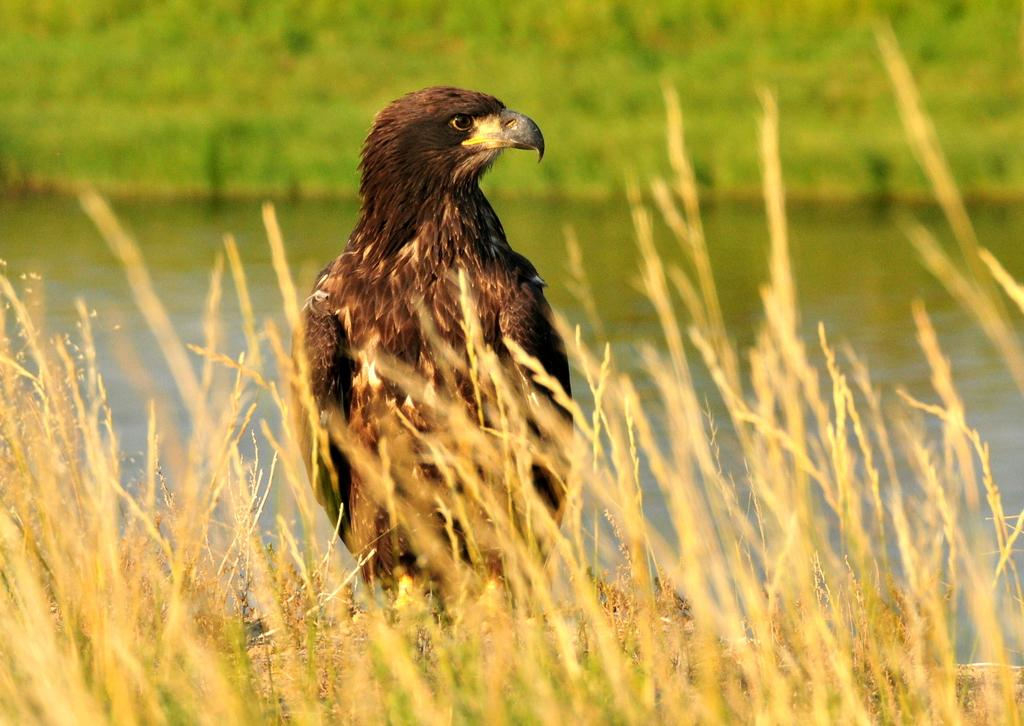What animal is the main subject of the picture? There is an eagle in the picture. In which direction is the eagle facing? The eagle is facing towards the right. What type of vegetation can be seen at the bottom of the image? There are dried plants at the bottom of the image. What natural features can be seen in the background of the image? There is a river and grass in the background of the image. What type of ink can be seen dripping from the jar in the image? There is no jar or ink present in the image; it features an eagle and dried plants. How many times does the eagle bite the grass in the image? There is no indication of the eagle biting the grass in the image. 